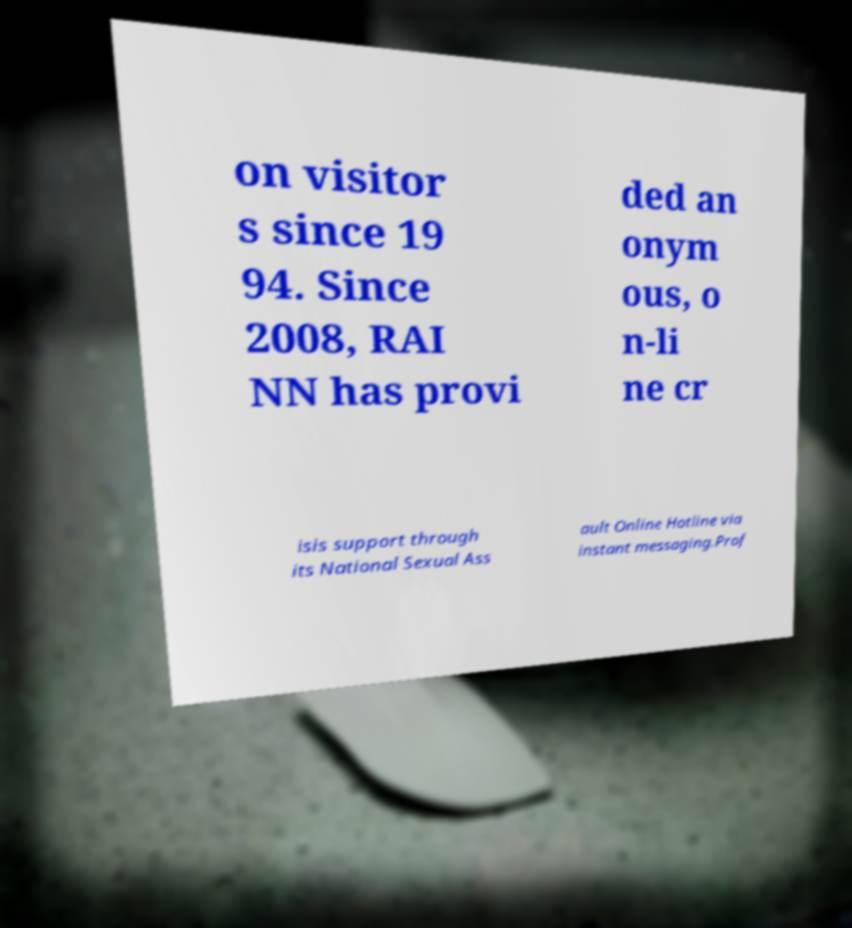Could you assist in decoding the text presented in this image and type it out clearly? on visitor s since 19 94. Since 2008, RAI NN has provi ded an onym ous, o n-li ne cr isis support through its National Sexual Ass ault Online Hotline via instant messaging.Prof 